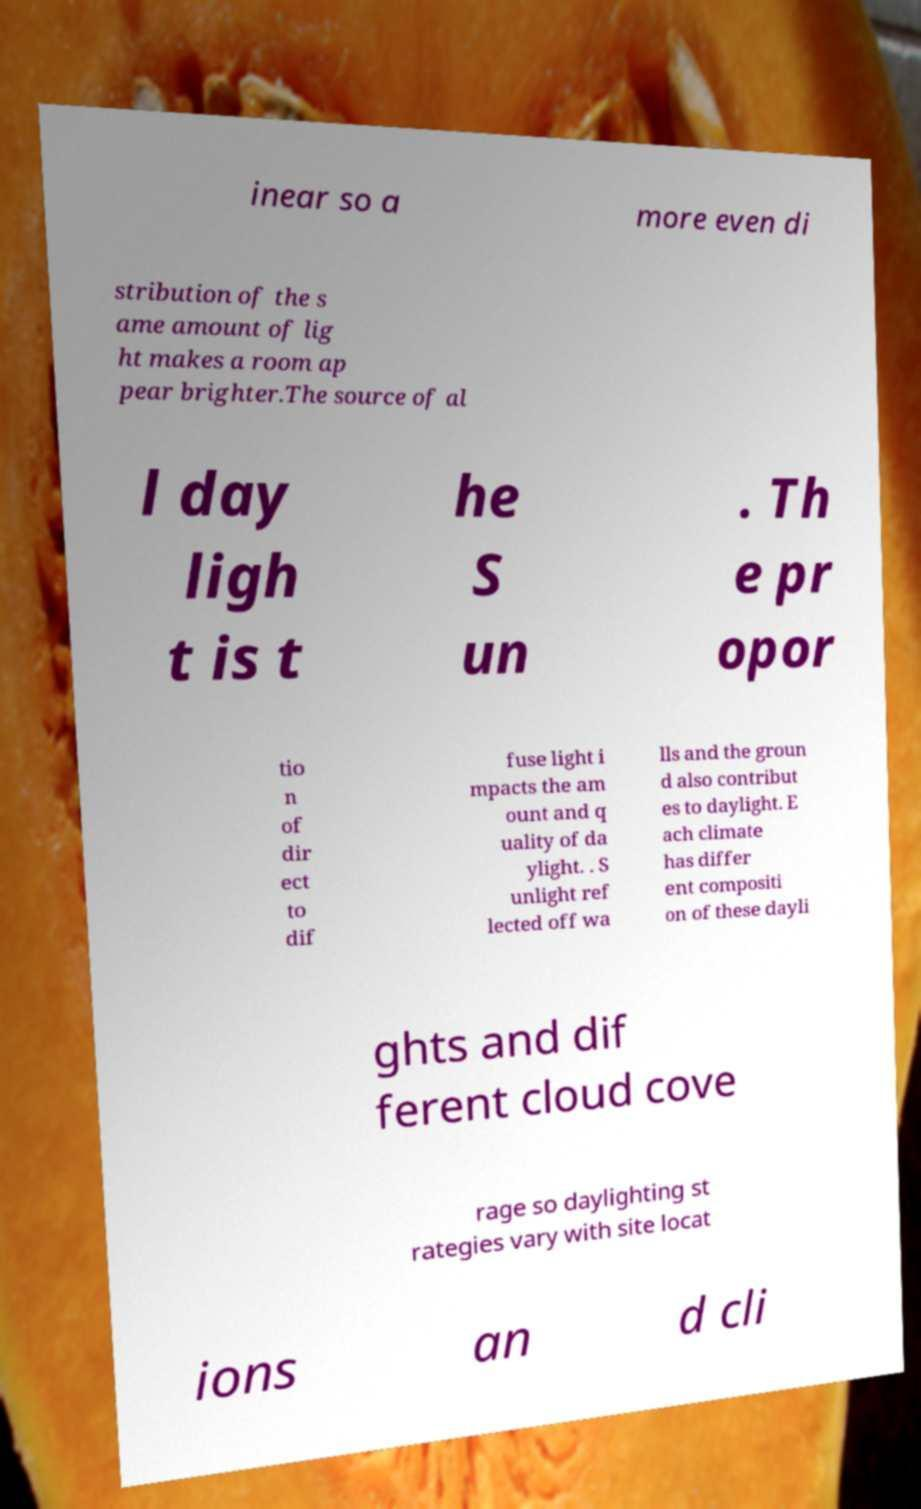Can you accurately transcribe the text from the provided image for me? inear so a more even di stribution of the s ame amount of lig ht makes a room ap pear brighter.The source of al l day ligh t is t he S un . Th e pr opor tio n of dir ect to dif fuse light i mpacts the am ount and q uality of da ylight. . S unlight ref lected off wa lls and the groun d also contribut es to daylight. E ach climate has differ ent compositi on of these dayli ghts and dif ferent cloud cove rage so daylighting st rategies vary with site locat ions an d cli 